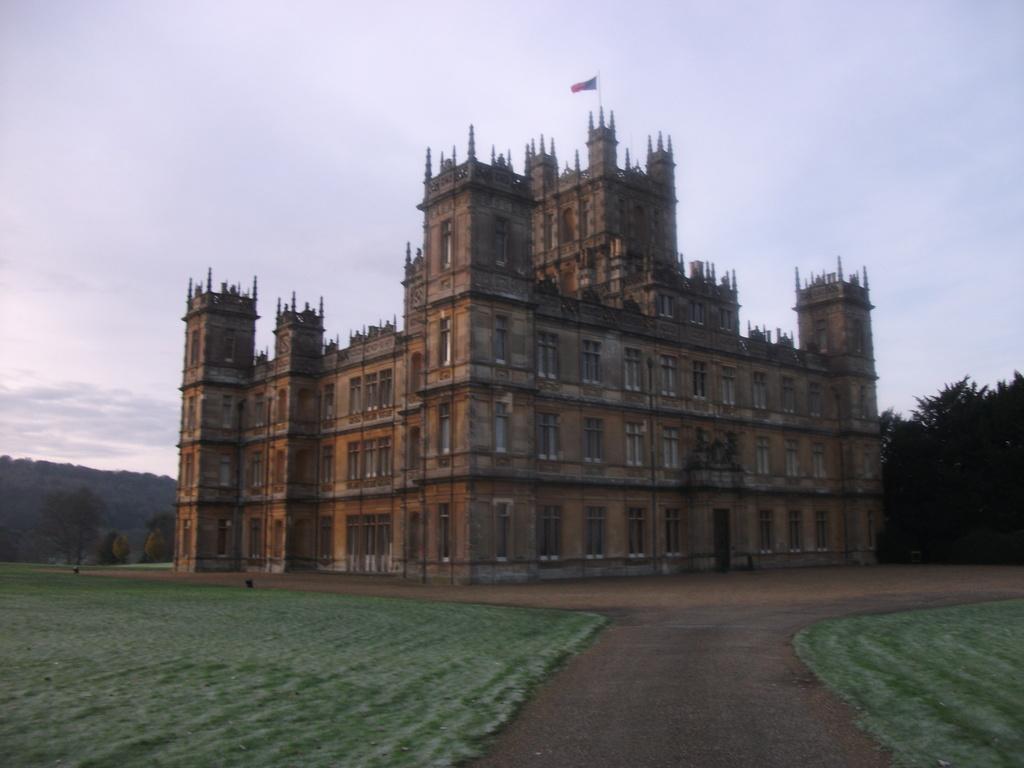Describe this image in one or two sentences. In this image I can see a building in the centre and on the bottom side of the image I can see grass grounds. On the both sides of the image I can see number of trees and in the background I can see clouds and the sky. On the top of the building I can see a flag. 